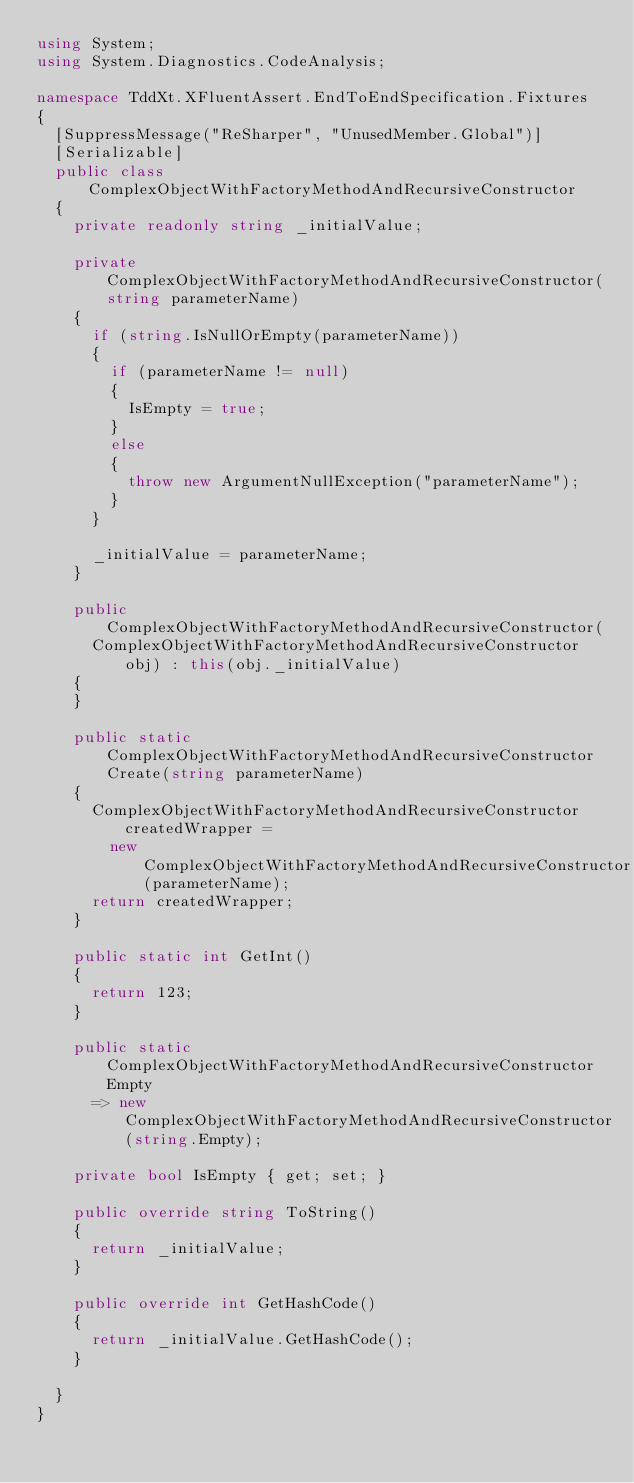Convert code to text. <code><loc_0><loc_0><loc_500><loc_500><_C#_>using System;
using System.Diagnostics.CodeAnalysis;

namespace TddXt.XFluentAssert.EndToEndSpecification.Fixtures
{
  [SuppressMessage("ReSharper", "UnusedMember.Global")]
  [Serializable]
  public class ComplexObjectWithFactoryMethodAndRecursiveConstructor
  {
    private readonly string _initialValue;

    private ComplexObjectWithFactoryMethodAndRecursiveConstructor(string parameterName)
    {
      if (string.IsNullOrEmpty(parameterName))
      {
        if (parameterName != null)
        {
          IsEmpty = true;
        }
        else
        {
          throw new ArgumentNullException("parameterName");
        }
      }

      _initialValue = parameterName;
    }

    public ComplexObjectWithFactoryMethodAndRecursiveConstructor(
      ComplexObjectWithFactoryMethodAndRecursiveConstructor obj) : this(obj._initialValue)
    {
    }

    public static ComplexObjectWithFactoryMethodAndRecursiveConstructor Create(string parameterName)
    {
      ComplexObjectWithFactoryMethodAndRecursiveConstructor createdWrapper =
        new ComplexObjectWithFactoryMethodAndRecursiveConstructor(parameterName);
      return createdWrapper;
    }

    public static int GetInt()
    {
      return 123;
    }

    public static ComplexObjectWithFactoryMethodAndRecursiveConstructor Empty
      => new ComplexObjectWithFactoryMethodAndRecursiveConstructor(string.Empty);

    private bool IsEmpty { get; set; }

    public override string ToString()
    {
      return _initialValue;
    }

    public override int GetHashCode()
    {
      return _initialValue.GetHashCode();
    }

  }
}</code> 